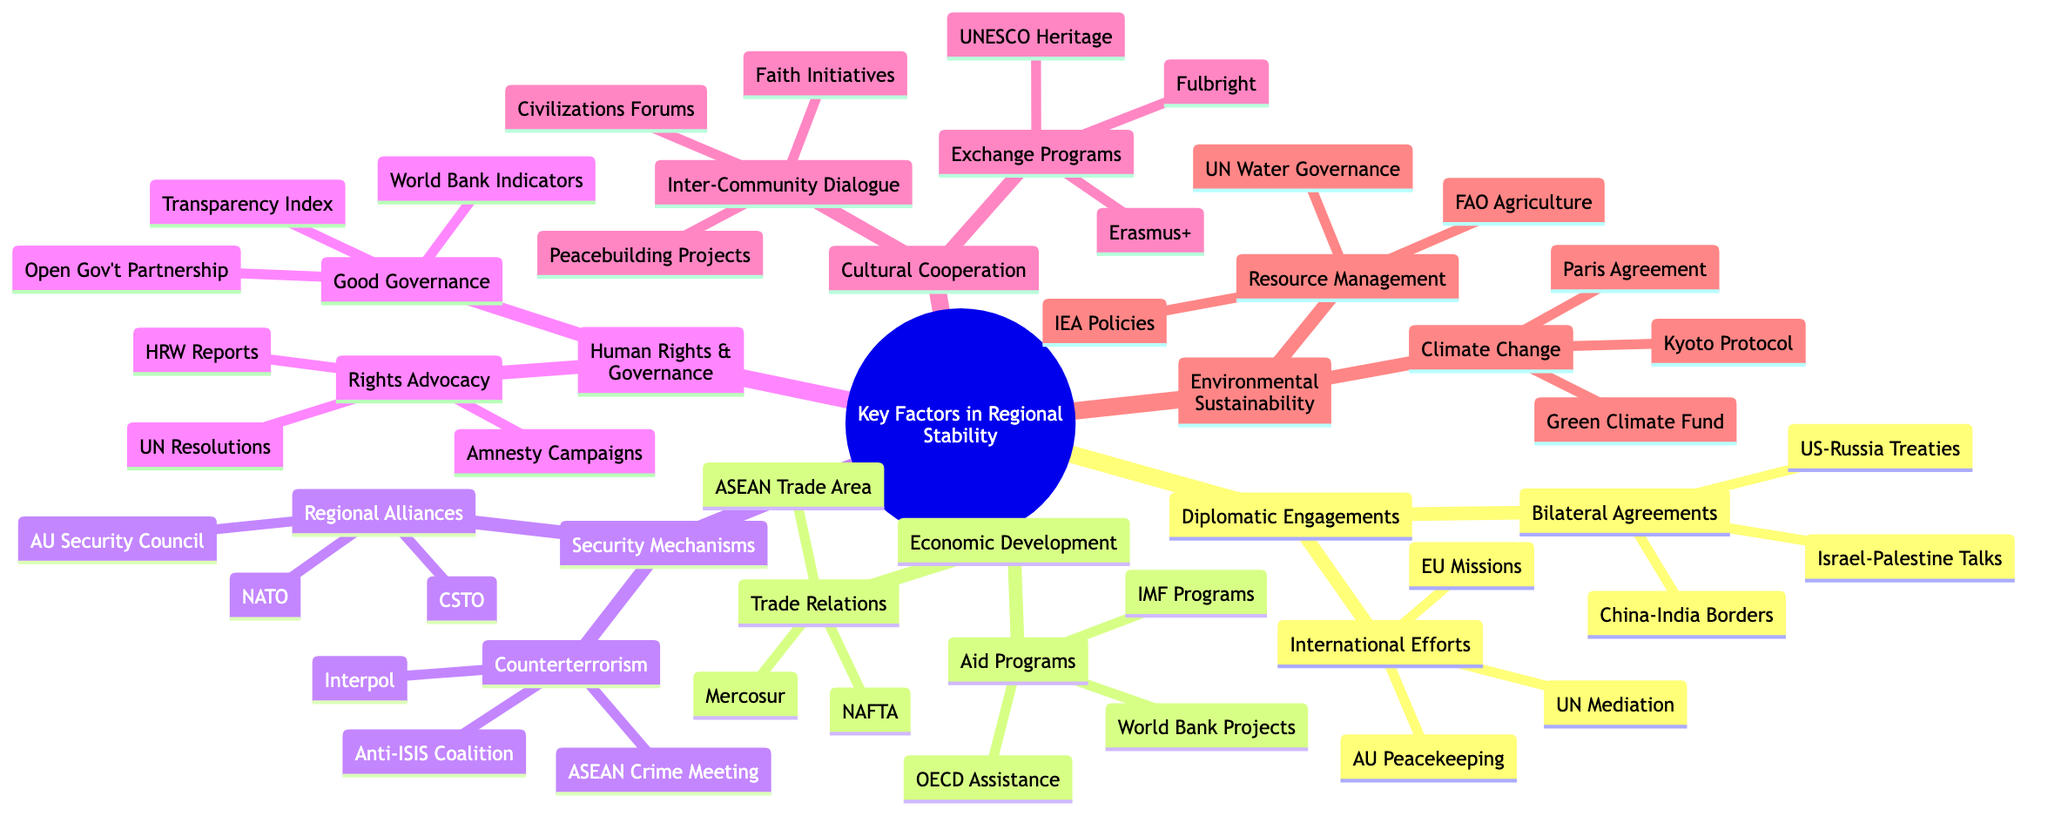What are the two main categories of key factors listed in the diagram? The diagram provides an overview of key factors in regional stability, which include six main categories: Diplomatic Engagements, Economic Development, Security Mechanisms, Human Rights and Governance, Cultural and Social Cooperation, and Environmental Sustainability.
Answer: Diplomatic Engagements, Economic Development How many international aid programs are mentioned under Economic Development? Within the Economic Development category, there are three international aid programs specifically listed: World Bank Development Projects, IMF Structural Adjustment Programs, and OECD Economic Assistance. Therefore, the total number is three.
Answer: 3 Which regional alliance is associated with Security Mechanisms? The Security Mechanisms category includes a node labeled "Regional Security Alliances," which specifically lists NATO Military Cooperation as one of the examples. Hence, the direct association is with NATO.
Answer: NATO What initiatives are listed under Climate Change Mitigation? Under Environmental Sustainability, the node referring to Climate Change Mitigation contains three specific initiatives: Paris Agreement Commitments, Kyoto Protocol Goals, and Green Climate Fund Projects.
Answer: Paris Agreement Commitments, Kyoto Protocol Goals, Green Climate Fund Projects How many bilateral agreements are mentioned in the Diplomatic Engagements section? In the Diplomatic Engagements section, there are three notable bilateral agreements identified: US-Russia Arms Control Treaties, China-India Border Agreements, and Israel-Palestine Peace Negotiations. Thus, the total number of bilateral agreements is three.
Answer: 3 Which organization is responsible for human rights advocacy according to the diagram? The Human Rights and Governance section includes a subcategory for Human Rights Advocacy, which cites Amnesty International as key among the examples listed. Therefore, the organization recognized for human rights advocacy in the diagram is Amnesty International.
Answer: Amnesty International What type of cooperation is mentioned in the Cultural Cooperation section? The Cultural Cooperation section includes several forms of cooperation, but specifically, it highlights two types: Cultural Exchange Programs and Inter-Community Dialogue as principal avenues for cultural cooperation.
Answer: Cultural Exchange Programs, Inter-Community Dialogue Which counterterrorism initiative is part of Security Mechanisms? In the Security Mechanisms category, the node for Counterterrorism Initiatives includes the "Global Coalition to Defeat ISIS" as one of the cited initiatives. Hence, this coalition represents a significant counterterrorism initiative listed in the diagram.
Answer: Global Coalition to Defeat ISIS What is one of the human rights organizations mentioned in the diagram? Within the Human Rights Advocacy subcategory, Human Rights Watch appears as one of the organizations notably mentioned. Thus, Human Rights Watch serves as an example of a human rights organization identified in the diagram.
Answer: Human Rights Watch 